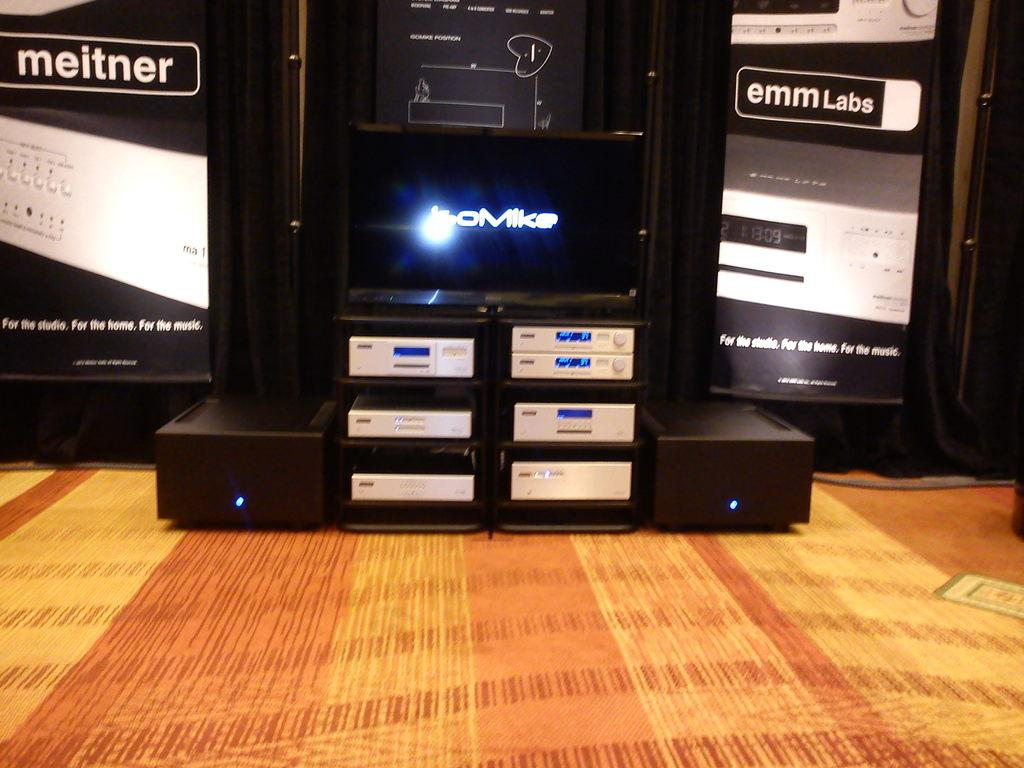<image>
Write a terse but informative summary of the picture. A display of high end electronic equipment contains some Meitner product. 